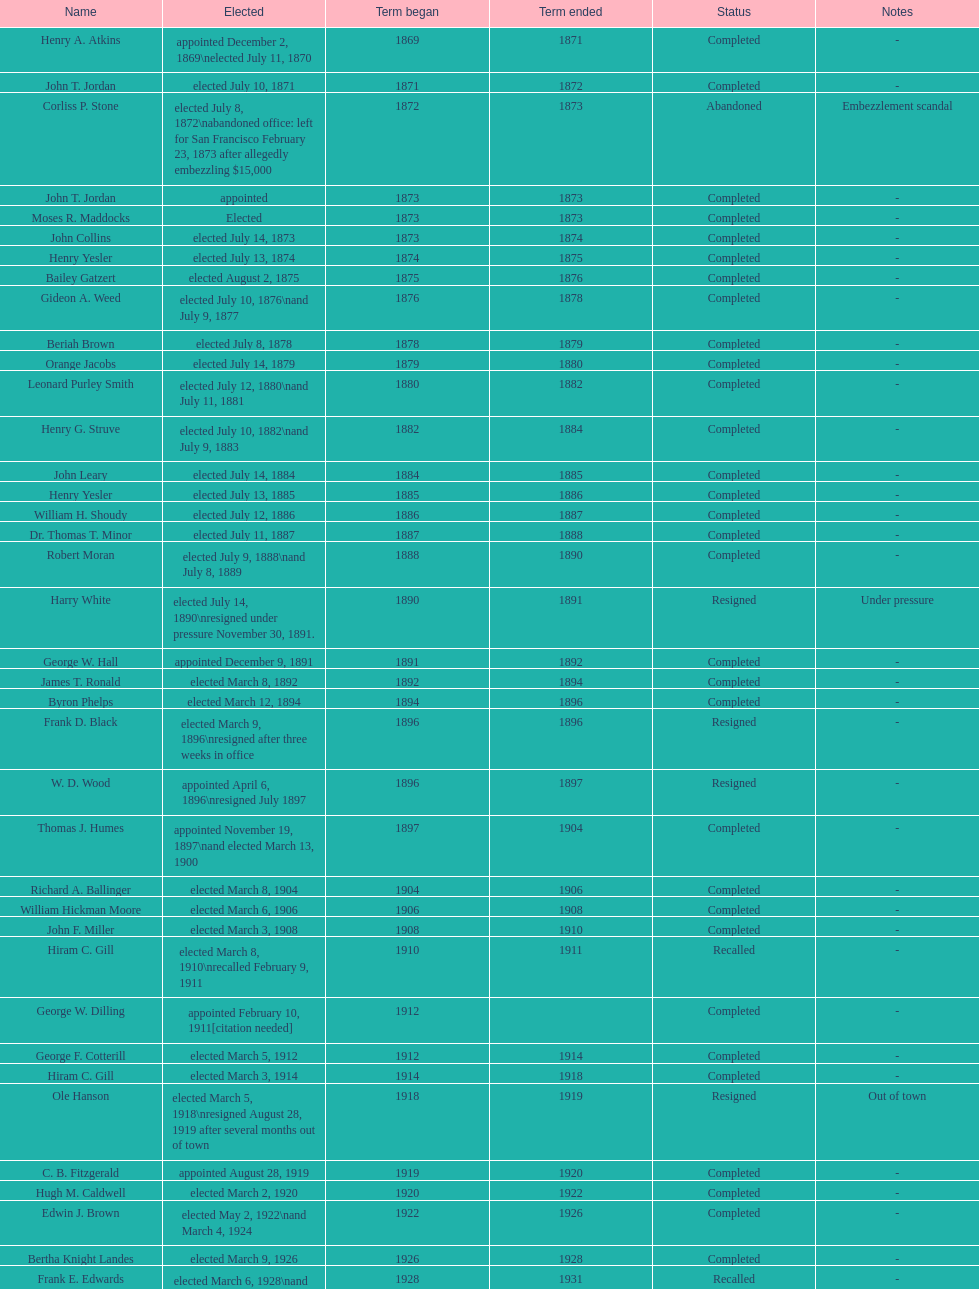Who was mayor of seattle, washington before being appointed to department of transportation during the nixon administration? James d'Orma Braman. 